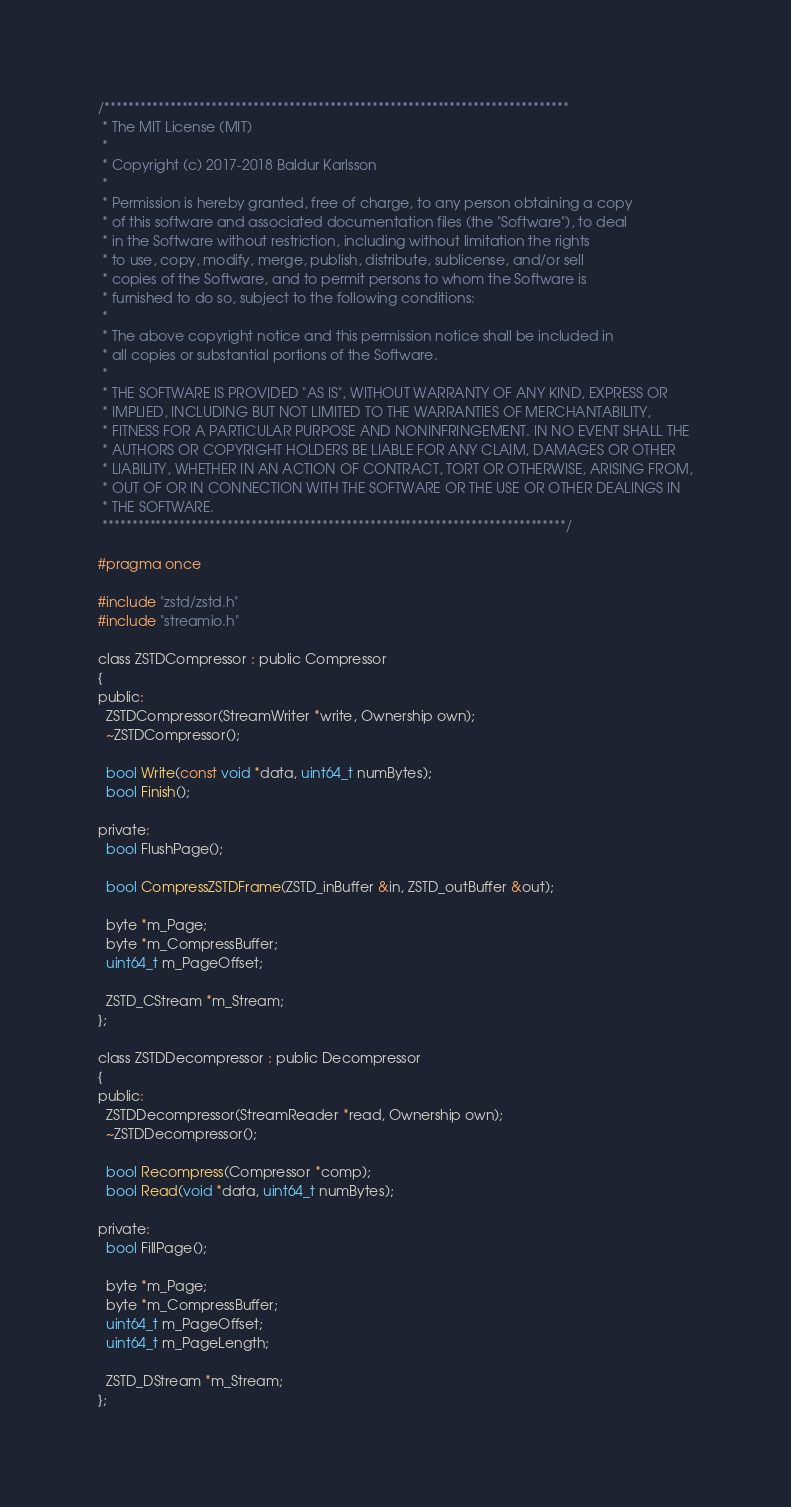<code> <loc_0><loc_0><loc_500><loc_500><_C_>/******************************************************************************
 * The MIT License (MIT)
 *
 * Copyright (c) 2017-2018 Baldur Karlsson
 *
 * Permission is hereby granted, free of charge, to any person obtaining a copy
 * of this software and associated documentation files (the "Software"), to deal
 * in the Software without restriction, including without limitation the rights
 * to use, copy, modify, merge, publish, distribute, sublicense, and/or sell
 * copies of the Software, and to permit persons to whom the Software is
 * furnished to do so, subject to the following conditions:
 *
 * The above copyright notice and this permission notice shall be included in
 * all copies or substantial portions of the Software.
 *
 * THE SOFTWARE IS PROVIDED "AS IS", WITHOUT WARRANTY OF ANY KIND, EXPRESS OR
 * IMPLIED, INCLUDING BUT NOT LIMITED TO THE WARRANTIES OF MERCHANTABILITY,
 * FITNESS FOR A PARTICULAR PURPOSE AND NONINFRINGEMENT. IN NO EVENT SHALL THE
 * AUTHORS OR COPYRIGHT HOLDERS BE LIABLE FOR ANY CLAIM, DAMAGES OR OTHER
 * LIABILITY, WHETHER IN AN ACTION OF CONTRACT, TORT OR OTHERWISE, ARISING FROM,
 * OUT OF OR IN CONNECTION WITH THE SOFTWARE OR THE USE OR OTHER DEALINGS IN
 * THE SOFTWARE.
 ******************************************************************************/

#pragma once

#include "zstd/zstd.h"
#include "streamio.h"

class ZSTDCompressor : public Compressor
{
public:
  ZSTDCompressor(StreamWriter *write, Ownership own);
  ~ZSTDCompressor();

  bool Write(const void *data, uint64_t numBytes);
  bool Finish();

private:
  bool FlushPage();

  bool CompressZSTDFrame(ZSTD_inBuffer &in, ZSTD_outBuffer &out);

  byte *m_Page;
  byte *m_CompressBuffer;
  uint64_t m_PageOffset;

  ZSTD_CStream *m_Stream;
};

class ZSTDDecompressor : public Decompressor
{
public:
  ZSTDDecompressor(StreamReader *read, Ownership own);
  ~ZSTDDecompressor();

  bool Recompress(Compressor *comp);
  bool Read(void *data, uint64_t numBytes);

private:
  bool FillPage();

  byte *m_Page;
  byte *m_CompressBuffer;
  uint64_t m_PageOffset;
  uint64_t m_PageLength;

  ZSTD_DStream *m_Stream;
};
</code> 